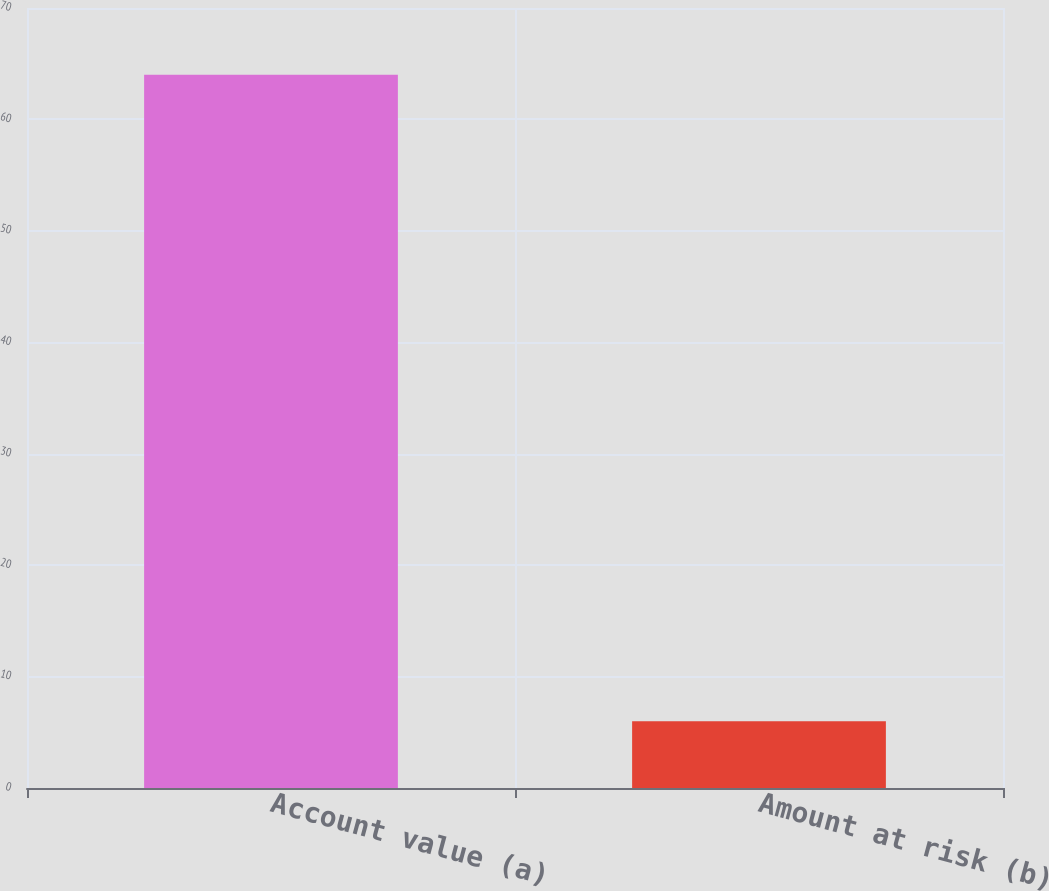<chart> <loc_0><loc_0><loc_500><loc_500><bar_chart><fcel>Account value (a)<fcel>Amount at risk (b)<nl><fcel>64<fcel>6<nl></chart> 